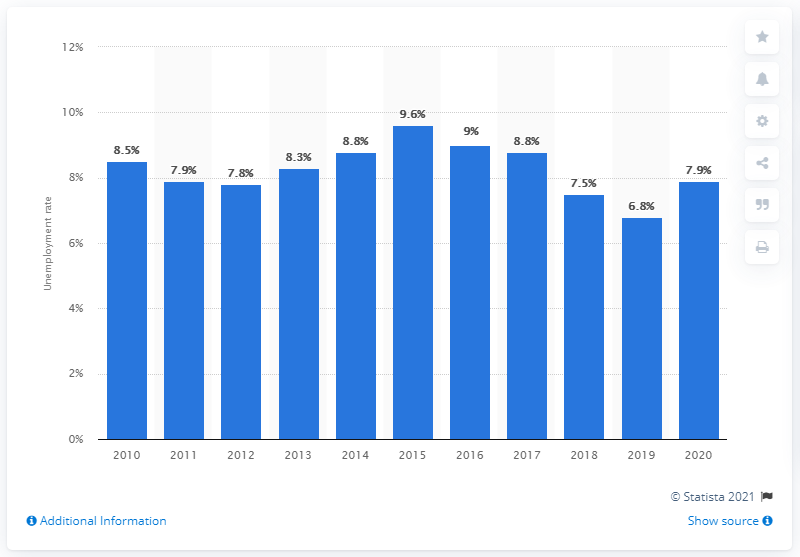Identify some key points in this picture. In 2020, the unemployment rate was 7.9%. 